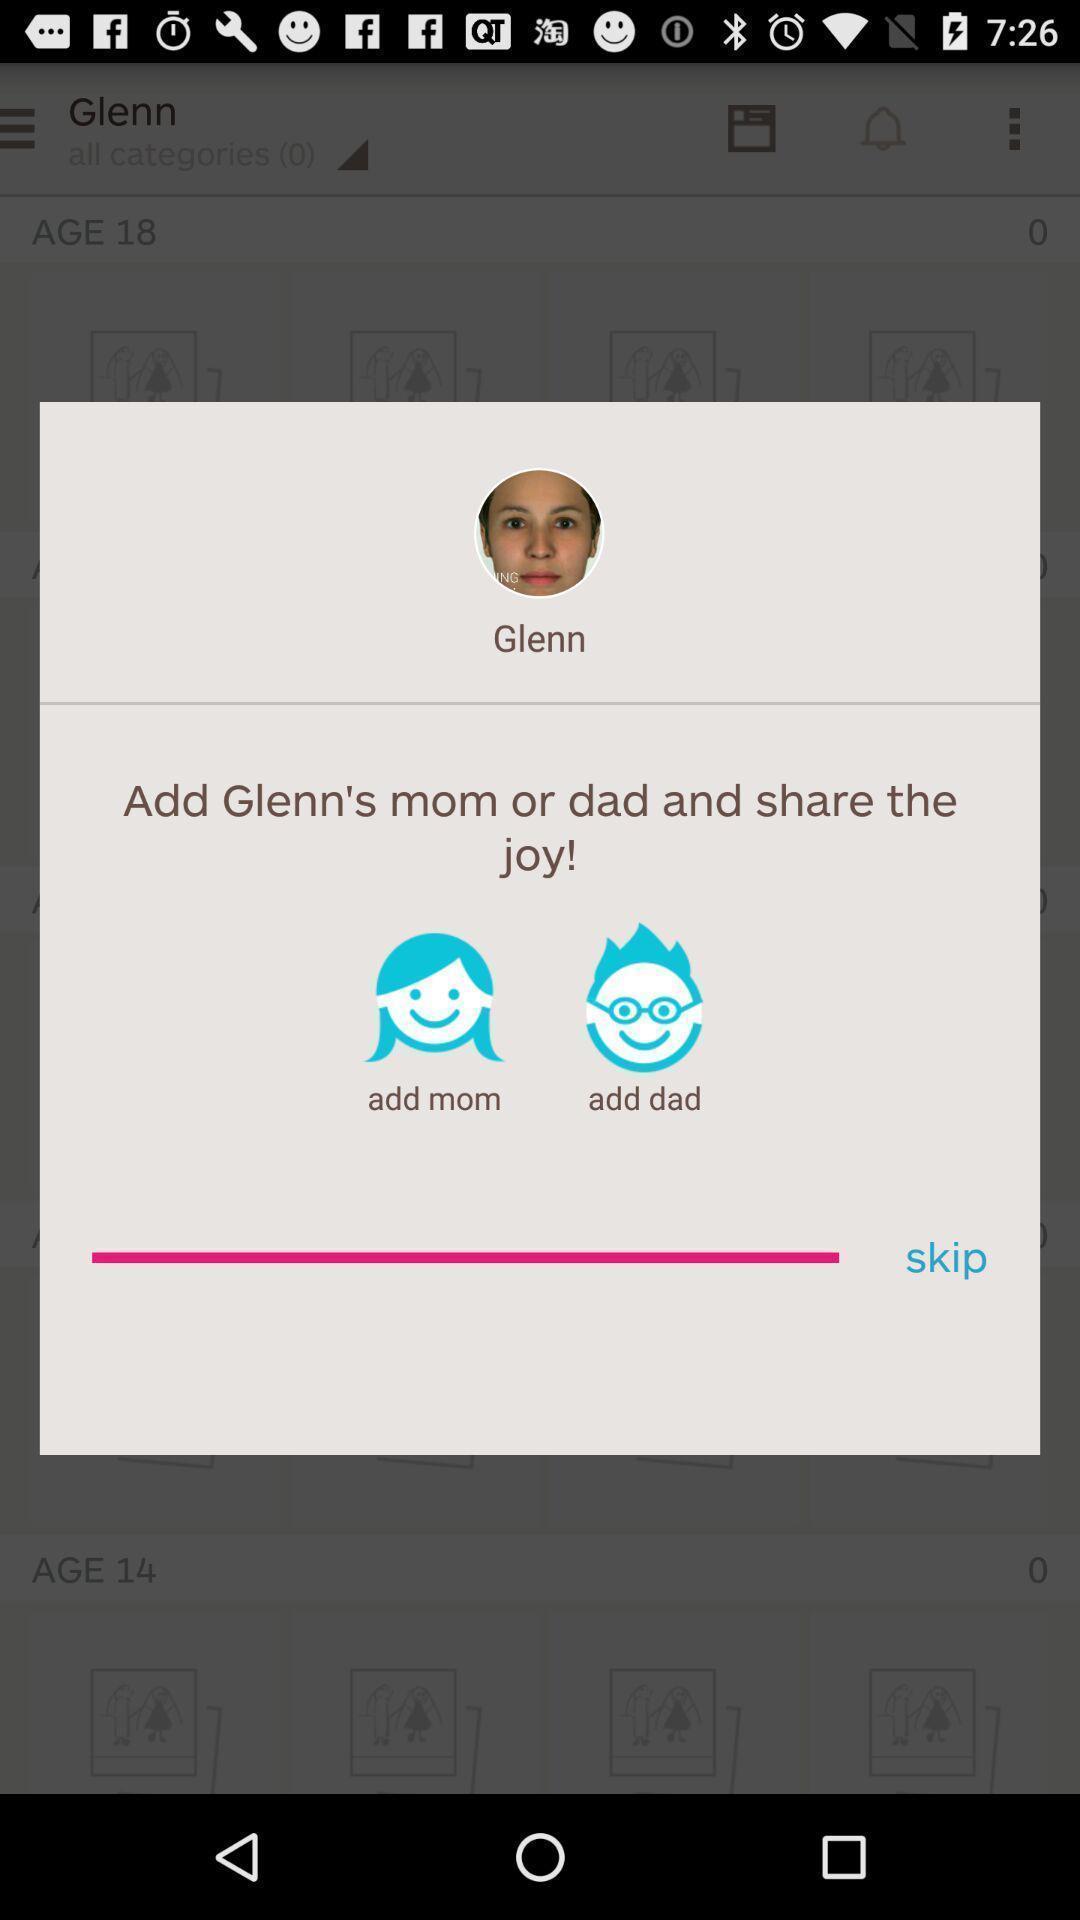Tell me about the visual elements in this screen capture. Pop-up showing to add parents to the profile or skip. 